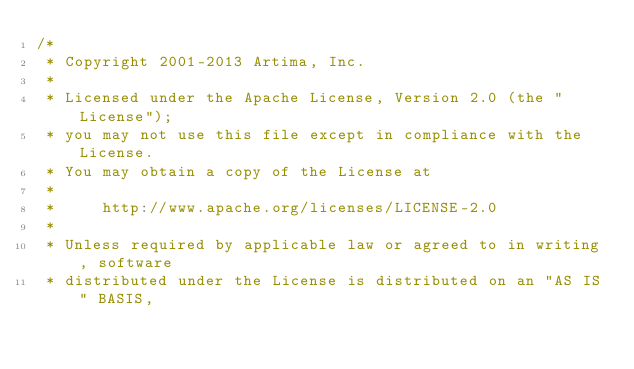<code> <loc_0><loc_0><loc_500><loc_500><_Scala_>/*
 * Copyright 2001-2013 Artima, Inc.
 *
 * Licensed under the Apache License, Version 2.0 (the "License");
 * you may not use this file except in compliance with the License.
 * You may obtain a copy of the License at
 *
 *     http://www.apache.org/licenses/LICENSE-2.0
 *
 * Unless required by applicable law or agreed to in writing, software
 * distributed under the License is distributed on an "AS IS" BASIS,</code> 